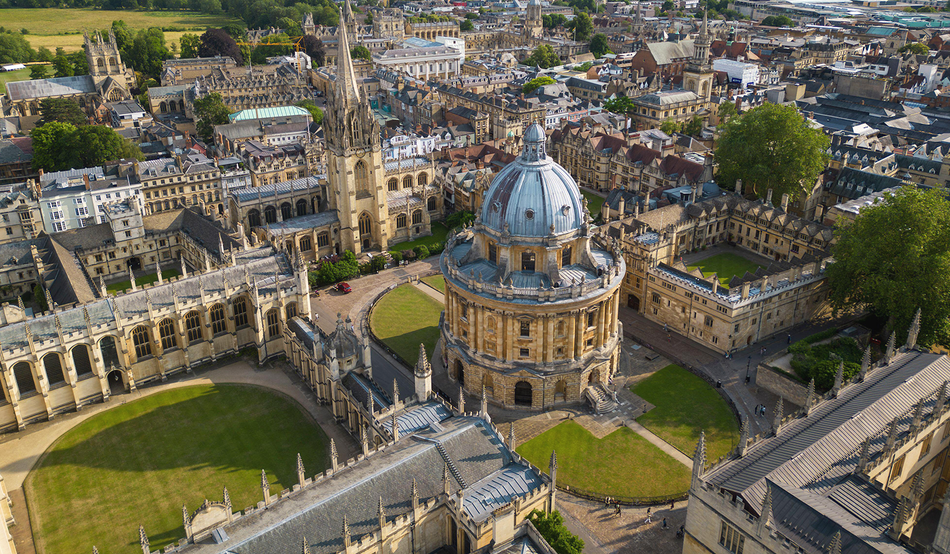What is it like for students studying here in the modern day compared to the past? Modern-day students at Oxford University enjoy the unique blend of historic tradition and cutting-edge research. They study in ancient halls and have access to unparalleled resources like centuries-old libraries, yet they engage with dynamic and diverse curricula. Technology has transformed the academic experience, with digital resources complementing traditional learning methods. Despite the passage of time, the essence of the Oxford education remains—a rigorous and enriching journey in the pursuit of knowledge. 